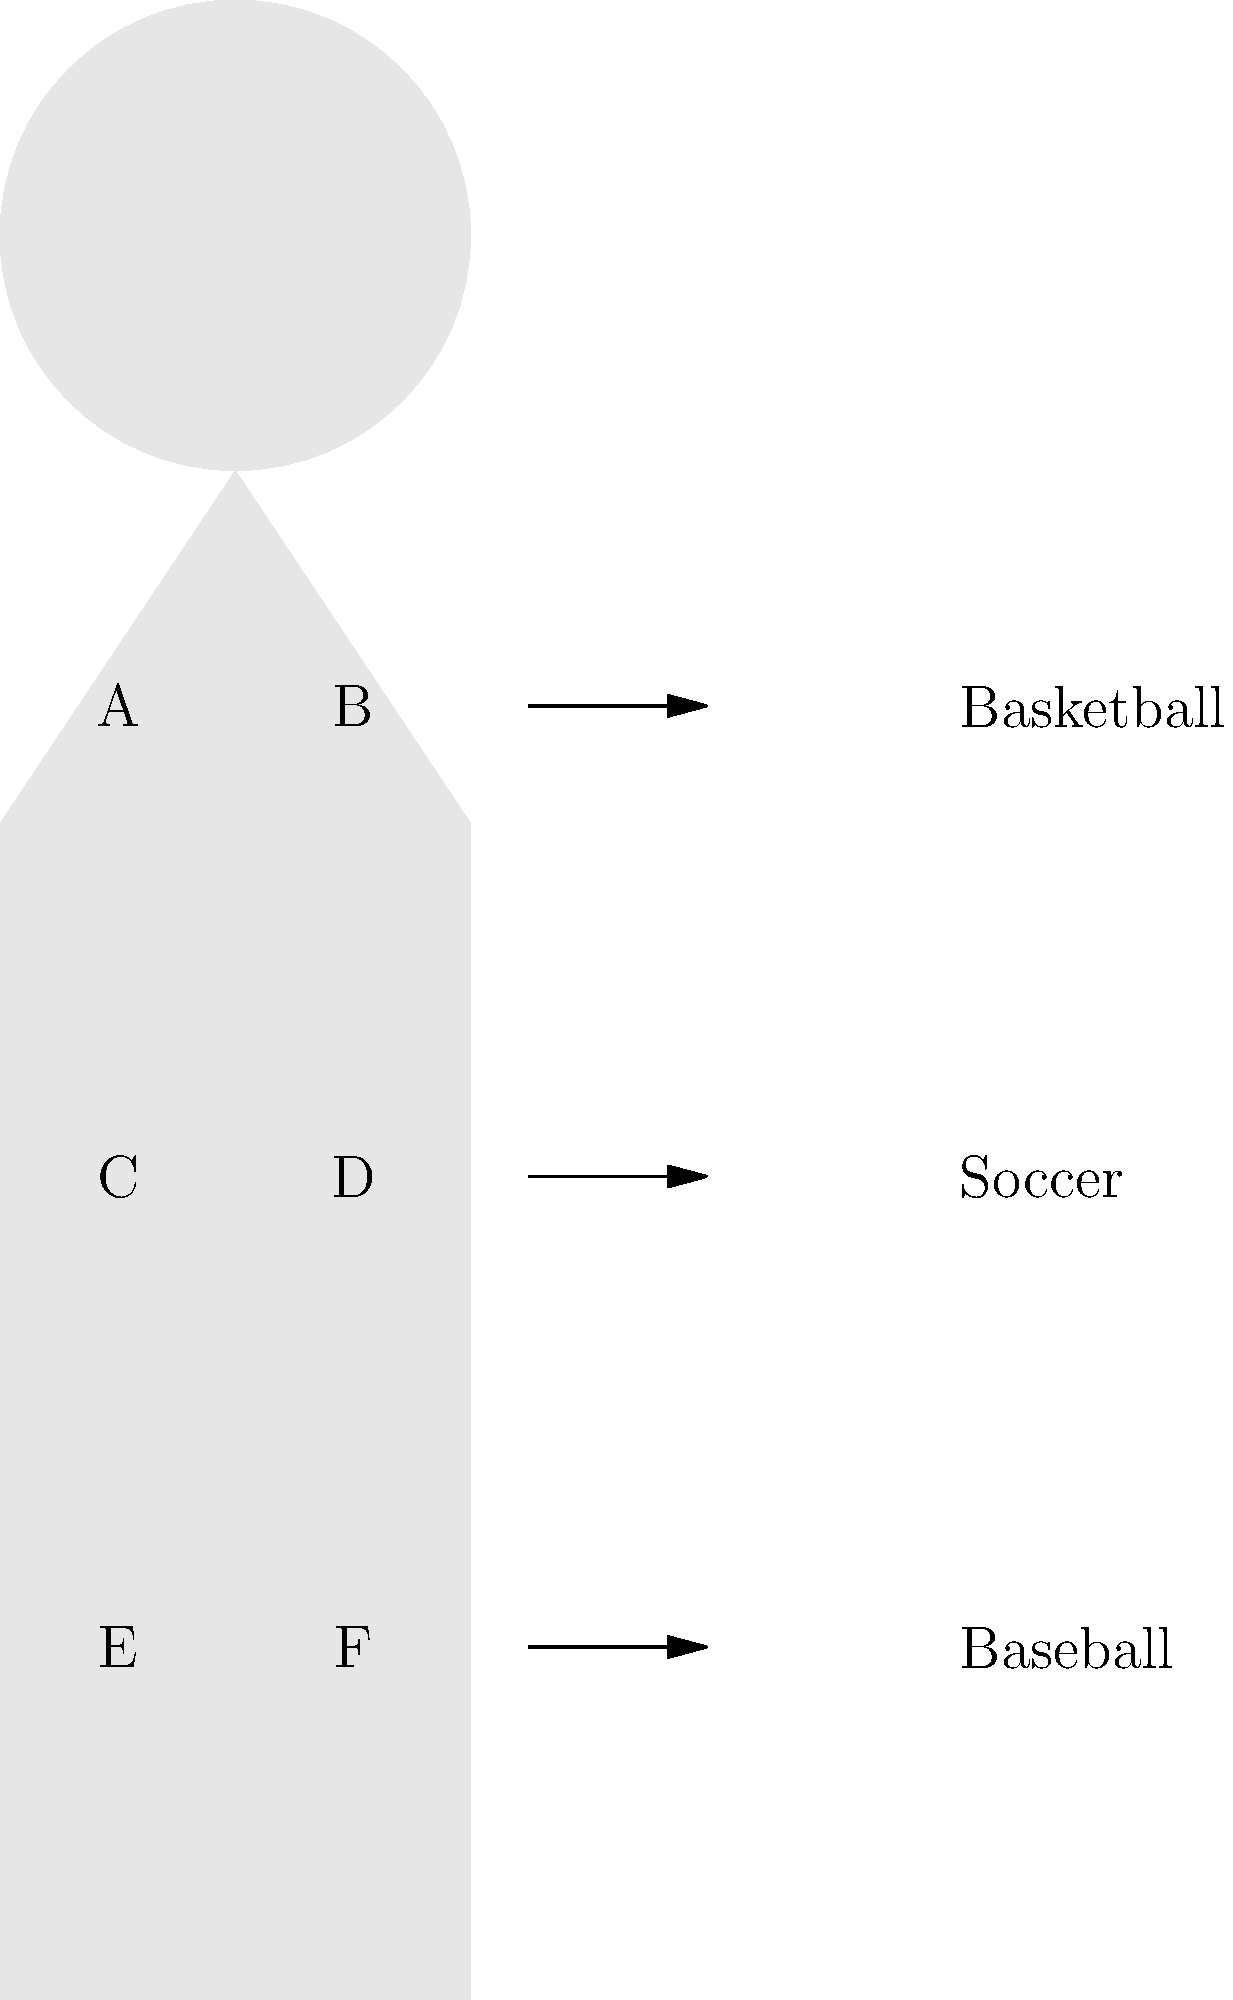In the diagram above, which muscle groups (labeled A-F) are primarily engaged when playing basketball, a traditional sport often emphasized in physical education classes? To answer this question, we need to consider the primary movements involved in basketball and match them to the muscle groups shown in the diagram:

1. Basketball involves a lot of jumping, which primarily engages the leg muscles.
2. The lower body muscle groups in the diagram are E and F, which represent the quadriceps and hamstrings, respectively.
3. Basketball also requires upper body strength for shooting and passing.
4. The upper body muscle groups in the diagram are A and B, which represent the chest (pectorals) and shoulders (deltoids), respectively.
5. The middle section, C and D, likely represent the abdominal and back muscles, which are used for stability but are not as primary in basketball as the others.

Therefore, the muscle groups primarily engaged when playing basketball are A, B, E, and F.
Answer: A, B, E, F 